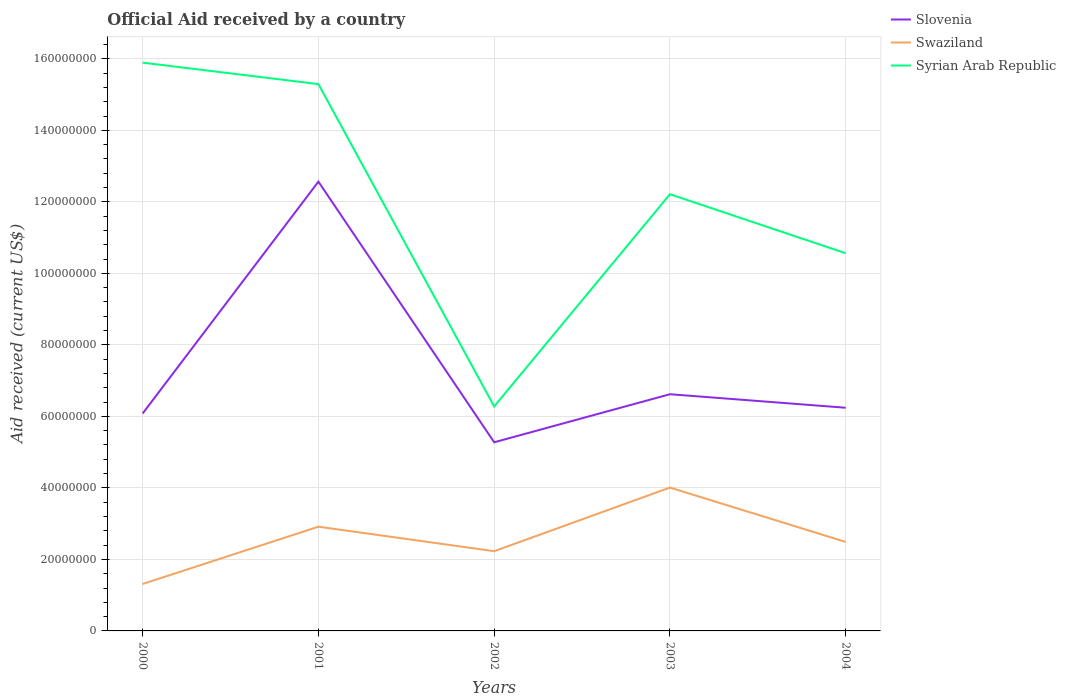How many different coloured lines are there?
Keep it short and to the point. 3. Is the number of lines equal to the number of legend labels?
Provide a short and direct response. Yes. Across all years, what is the maximum net official aid received in Slovenia?
Make the answer very short. 5.28e+07. What is the total net official aid received in Slovenia in the graph?
Your response must be concise. -5.39e+06. What is the difference between the highest and the second highest net official aid received in Syrian Arab Republic?
Provide a short and direct response. 9.62e+07. How many lines are there?
Offer a terse response. 3. Are the values on the major ticks of Y-axis written in scientific E-notation?
Offer a very short reply. No. Does the graph contain any zero values?
Offer a terse response. No. Does the graph contain grids?
Offer a very short reply. Yes. Where does the legend appear in the graph?
Provide a succinct answer. Top right. How many legend labels are there?
Offer a terse response. 3. How are the legend labels stacked?
Ensure brevity in your answer.  Vertical. What is the title of the graph?
Your answer should be compact. Official Aid received by a country. What is the label or title of the X-axis?
Provide a short and direct response. Years. What is the label or title of the Y-axis?
Ensure brevity in your answer.  Aid received (current US$). What is the Aid received (current US$) in Slovenia in 2000?
Your answer should be very brief. 6.08e+07. What is the Aid received (current US$) in Swaziland in 2000?
Offer a terse response. 1.31e+07. What is the Aid received (current US$) in Syrian Arab Republic in 2000?
Keep it short and to the point. 1.59e+08. What is the Aid received (current US$) in Slovenia in 2001?
Offer a terse response. 1.26e+08. What is the Aid received (current US$) in Swaziland in 2001?
Offer a very short reply. 2.92e+07. What is the Aid received (current US$) in Syrian Arab Republic in 2001?
Offer a terse response. 1.53e+08. What is the Aid received (current US$) of Slovenia in 2002?
Offer a very short reply. 5.28e+07. What is the Aid received (current US$) of Swaziland in 2002?
Provide a succinct answer. 2.23e+07. What is the Aid received (current US$) of Syrian Arab Republic in 2002?
Your answer should be compact. 6.28e+07. What is the Aid received (current US$) of Slovenia in 2003?
Your answer should be compact. 6.62e+07. What is the Aid received (current US$) in Swaziland in 2003?
Offer a terse response. 4.01e+07. What is the Aid received (current US$) in Syrian Arab Republic in 2003?
Provide a succinct answer. 1.22e+08. What is the Aid received (current US$) in Slovenia in 2004?
Make the answer very short. 6.24e+07. What is the Aid received (current US$) in Swaziland in 2004?
Provide a short and direct response. 2.49e+07. What is the Aid received (current US$) in Syrian Arab Republic in 2004?
Keep it short and to the point. 1.06e+08. Across all years, what is the maximum Aid received (current US$) in Slovenia?
Ensure brevity in your answer.  1.26e+08. Across all years, what is the maximum Aid received (current US$) in Swaziland?
Offer a very short reply. 4.01e+07. Across all years, what is the maximum Aid received (current US$) in Syrian Arab Republic?
Provide a succinct answer. 1.59e+08. Across all years, what is the minimum Aid received (current US$) of Slovenia?
Ensure brevity in your answer.  5.28e+07. Across all years, what is the minimum Aid received (current US$) in Swaziland?
Offer a terse response. 1.31e+07. Across all years, what is the minimum Aid received (current US$) of Syrian Arab Republic?
Make the answer very short. 6.28e+07. What is the total Aid received (current US$) of Slovenia in the graph?
Provide a short and direct response. 3.68e+08. What is the total Aid received (current US$) in Swaziland in the graph?
Make the answer very short. 1.30e+08. What is the total Aid received (current US$) in Syrian Arab Republic in the graph?
Make the answer very short. 6.02e+08. What is the difference between the Aid received (current US$) of Slovenia in 2000 and that in 2001?
Offer a very short reply. -6.48e+07. What is the difference between the Aid received (current US$) of Swaziland in 2000 and that in 2001?
Your response must be concise. -1.60e+07. What is the difference between the Aid received (current US$) in Slovenia in 2000 and that in 2002?
Provide a short and direct response. 8.05e+06. What is the difference between the Aid received (current US$) in Swaziland in 2000 and that in 2002?
Your response must be concise. -9.17e+06. What is the difference between the Aid received (current US$) in Syrian Arab Republic in 2000 and that in 2002?
Offer a very short reply. 9.62e+07. What is the difference between the Aid received (current US$) in Slovenia in 2000 and that in 2003?
Your answer should be compact. -5.39e+06. What is the difference between the Aid received (current US$) in Swaziland in 2000 and that in 2003?
Ensure brevity in your answer.  -2.70e+07. What is the difference between the Aid received (current US$) in Syrian Arab Republic in 2000 and that in 2003?
Your answer should be very brief. 3.68e+07. What is the difference between the Aid received (current US$) of Slovenia in 2000 and that in 2004?
Make the answer very short. -1.61e+06. What is the difference between the Aid received (current US$) in Swaziland in 2000 and that in 2004?
Make the answer very short. -1.18e+07. What is the difference between the Aid received (current US$) of Syrian Arab Republic in 2000 and that in 2004?
Your response must be concise. 5.33e+07. What is the difference between the Aid received (current US$) in Slovenia in 2001 and that in 2002?
Ensure brevity in your answer.  7.29e+07. What is the difference between the Aid received (current US$) of Swaziland in 2001 and that in 2002?
Provide a succinct answer. 6.85e+06. What is the difference between the Aid received (current US$) in Syrian Arab Republic in 2001 and that in 2002?
Provide a short and direct response. 9.02e+07. What is the difference between the Aid received (current US$) in Slovenia in 2001 and that in 2003?
Your answer should be compact. 5.95e+07. What is the difference between the Aid received (current US$) in Swaziland in 2001 and that in 2003?
Keep it short and to the point. -1.09e+07. What is the difference between the Aid received (current US$) of Syrian Arab Republic in 2001 and that in 2003?
Offer a terse response. 3.08e+07. What is the difference between the Aid received (current US$) in Slovenia in 2001 and that in 2004?
Your answer should be compact. 6.32e+07. What is the difference between the Aid received (current US$) of Swaziland in 2001 and that in 2004?
Offer a very short reply. 4.26e+06. What is the difference between the Aid received (current US$) of Syrian Arab Republic in 2001 and that in 2004?
Your answer should be compact. 4.73e+07. What is the difference between the Aid received (current US$) of Slovenia in 2002 and that in 2003?
Your response must be concise. -1.34e+07. What is the difference between the Aid received (current US$) in Swaziland in 2002 and that in 2003?
Your answer should be compact. -1.78e+07. What is the difference between the Aid received (current US$) of Syrian Arab Republic in 2002 and that in 2003?
Offer a very short reply. -5.94e+07. What is the difference between the Aid received (current US$) in Slovenia in 2002 and that in 2004?
Keep it short and to the point. -9.66e+06. What is the difference between the Aid received (current US$) of Swaziland in 2002 and that in 2004?
Make the answer very short. -2.59e+06. What is the difference between the Aid received (current US$) in Syrian Arab Republic in 2002 and that in 2004?
Ensure brevity in your answer.  -4.28e+07. What is the difference between the Aid received (current US$) in Slovenia in 2003 and that in 2004?
Make the answer very short. 3.78e+06. What is the difference between the Aid received (current US$) of Swaziland in 2003 and that in 2004?
Your answer should be very brief. 1.52e+07. What is the difference between the Aid received (current US$) of Syrian Arab Republic in 2003 and that in 2004?
Ensure brevity in your answer.  1.65e+07. What is the difference between the Aid received (current US$) in Slovenia in 2000 and the Aid received (current US$) in Swaziland in 2001?
Give a very brief answer. 3.17e+07. What is the difference between the Aid received (current US$) of Slovenia in 2000 and the Aid received (current US$) of Syrian Arab Republic in 2001?
Your response must be concise. -9.21e+07. What is the difference between the Aid received (current US$) in Swaziland in 2000 and the Aid received (current US$) in Syrian Arab Republic in 2001?
Your response must be concise. -1.40e+08. What is the difference between the Aid received (current US$) in Slovenia in 2000 and the Aid received (current US$) in Swaziland in 2002?
Your answer should be very brief. 3.85e+07. What is the difference between the Aid received (current US$) of Slovenia in 2000 and the Aid received (current US$) of Syrian Arab Republic in 2002?
Make the answer very short. -1.97e+06. What is the difference between the Aid received (current US$) of Swaziland in 2000 and the Aid received (current US$) of Syrian Arab Republic in 2002?
Your response must be concise. -4.96e+07. What is the difference between the Aid received (current US$) of Slovenia in 2000 and the Aid received (current US$) of Swaziland in 2003?
Offer a terse response. 2.07e+07. What is the difference between the Aid received (current US$) in Slovenia in 2000 and the Aid received (current US$) in Syrian Arab Republic in 2003?
Give a very brief answer. -6.13e+07. What is the difference between the Aid received (current US$) of Swaziland in 2000 and the Aid received (current US$) of Syrian Arab Republic in 2003?
Give a very brief answer. -1.09e+08. What is the difference between the Aid received (current US$) of Slovenia in 2000 and the Aid received (current US$) of Swaziland in 2004?
Your answer should be very brief. 3.59e+07. What is the difference between the Aid received (current US$) in Slovenia in 2000 and the Aid received (current US$) in Syrian Arab Republic in 2004?
Your answer should be compact. -4.48e+07. What is the difference between the Aid received (current US$) of Swaziland in 2000 and the Aid received (current US$) of Syrian Arab Republic in 2004?
Make the answer very short. -9.25e+07. What is the difference between the Aid received (current US$) in Slovenia in 2001 and the Aid received (current US$) in Swaziland in 2002?
Your response must be concise. 1.03e+08. What is the difference between the Aid received (current US$) of Slovenia in 2001 and the Aid received (current US$) of Syrian Arab Republic in 2002?
Offer a very short reply. 6.29e+07. What is the difference between the Aid received (current US$) in Swaziland in 2001 and the Aid received (current US$) in Syrian Arab Republic in 2002?
Your answer should be compact. -3.36e+07. What is the difference between the Aid received (current US$) of Slovenia in 2001 and the Aid received (current US$) of Swaziland in 2003?
Offer a terse response. 8.56e+07. What is the difference between the Aid received (current US$) of Slovenia in 2001 and the Aid received (current US$) of Syrian Arab Republic in 2003?
Your answer should be compact. 3.52e+06. What is the difference between the Aid received (current US$) of Swaziland in 2001 and the Aid received (current US$) of Syrian Arab Republic in 2003?
Provide a short and direct response. -9.30e+07. What is the difference between the Aid received (current US$) of Slovenia in 2001 and the Aid received (current US$) of Swaziland in 2004?
Give a very brief answer. 1.01e+08. What is the difference between the Aid received (current US$) of Slovenia in 2001 and the Aid received (current US$) of Syrian Arab Republic in 2004?
Keep it short and to the point. 2.00e+07. What is the difference between the Aid received (current US$) in Swaziland in 2001 and the Aid received (current US$) in Syrian Arab Republic in 2004?
Your response must be concise. -7.65e+07. What is the difference between the Aid received (current US$) of Slovenia in 2002 and the Aid received (current US$) of Swaziland in 2003?
Keep it short and to the point. 1.27e+07. What is the difference between the Aid received (current US$) of Slovenia in 2002 and the Aid received (current US$) of Syrian Arab Republic in 2003?
Provide a succinct answer. -6.94e+07. What is the difference between the Aid received (current US$) of Swaziland in 2002 and the Aid received (current US$) of Syrian Arab Republic in 2003?
Your answer should be very brief. -9.98e+07. What is the difference between the Aid received (current US$) in Slovenia in 2002 and the Aid received (current US$) in Swaziland in 2004?
Your response must be concise. 2.79e+07. What is the difference between the Aid received (current US$) in Slovenia in 2002 and the Aid received (current US$) in Syrian Arab Republic in 2004?
Give a very brief answer. -5.29e+07. What is the difference between the Aid received (current US$) of Swaziland in 2002 and the Aid received (current US$) of Syrian Arab Republic in 2004?
Keep it short and to the point. -8.33e+07. What is the difference between the Aid received (current US$) in Slovenia in 2003 and the Aid received (current US$) in Swaziland in 2004?
Offer a terse response. 4.13e+07. What is the difference between the Aid received (current US$) of Slovenia in 2003 and the Aid received (current US$) of Syrian Arab Republic in 2004?
Your response must be concise. -3.94e+07. What is the difference between the Aid received (current US$) in Swaziland in 2003 and the Aid received (current US$) in Syrian Arab Republic in 2004?
Your answer should be compact. -6.55e+07. What is the average Aid received (current US$) in Slovenia per year?
Your answer should be compact. 7.36e+07. What is the average Aid received (current US$) in Swaziland per year?
Provide a succinct answer. 2.59e+07. What is the average Aid received (current US$) in Syrian Arab Republic per year?
Your answer should be very brief. 1.20e+08. In the year 2000, what is the difference between the Aid received (current US$) of Slovenia and Aid received (current US$) of Swaziland?
Offer a terse response. 4.77e+07. In the year 2000, what is the difference between the Aid received (current US$) of Slovenia and Aid received (current US$) of Syrian Arab Republic?
Your answer should be very brief. -9.81e+07. In the year 2000, what is the difference between the Aid received (current US$) in Swaziland and Aid received (current US$) in Syrian Arab Republic?
Your answer should be compact. -1.46e+08. In the year 2001, what is the difference between the Aid received (current US$) of Slovenia and Aid received (current US$) of Swaziland?
Provide a short and direct response. 9.65e+07. In the year 2001, what is the difference between the Aid received (current US$) of Slovenia and Aid received (current US$) of Syrian Arab Republic?
Make the answer very short. -2.73e+07. In the year 2001, what is the difference between the Aid received (current US$) in Swaziland and Aid received (current US$) in Syrian Arab Republic?
Provide a short and direct response. -1.24e+08. In the year 2002, what is the difference between the Aid received (current US$) of Slovenia and Aid received (current US$) of Swaziland?
Make the answer very short. 3.05e+07. In the year 2002, what is the difference between the Aid received (current US$) of Slovenia and Aid received (current US$) of Syrian Arab Republic?
Your response must be concise. -1.00e+07. In the year 2002, what is the difference between the Aid received (current US$) in Swaziland and Aid received (current US$) in Syrian Arab Republic?
Ensure brevity in your answer.  -4.05e+07. In the year 2003, what is the difference between the Aid received (current US$) in Slovenia and Aid received (current US$) in Swaziland?
Offer a terse response. 2.61e+07. In the year 2003, what is the difference between the Aid received (current US$) in Slovenia and Aid received (current US$) in Syrian Arab Republic?
Keep it short and to the point. -5.59e+07. In the year 2003, what is the difference between the Aid received (current US$) of Swaziland and Aid received (current US$) of Syrian Arab Republic?
Your answer should be compact. -8.20e+07. In the year 2004, what is the difference between the Aid received (current US$) of Slovenia and Aid received (current US$) of Swaziland?
Give a very brief answer. 3.75e+07. In the year 2004, what is the difference between the Aid received (current US$) in Slovenia and Aid received (current US$) in Syrian Arab Republic?
Provide a short and direct response. -4.32e+07. In the year 2004, what is the difference between the Aid received (current US$) in Swaziland and Aid received (current US$) in Syrian Arab Republic?
Offer a terse response. -8.07e+07. What is the ratio of the Aid received (current US$) of Slovenia in 2000 to that in 2001?
Your answer should be compact. 0.48. What is the ratio of the Aid received (current US$) of Swaziland in 2000 to that in 2001?
Give a very brief answer. 0.45. What is the ratio of the Aid received (current US$) in Syrian Arab Republic in 2000 to that in 2001?
Your response must be concise. 1.04. What is the ratio of the Aid received (current US$) in Slovenia in 2000 to that in 2002?
Offer a terse response. 1.15. What is the ratio of the Aid received (current US$) of Swaziland in 2000 to that in 2002?
Offer a terse response. 0.59. What is the ratio of the Aid received (current US$) of Syrian Arab Republic in 2000 to that in 2002?
Offer a very short reply. 2.53. What is the ratio of the Aid received (current US$) in Slovenia in 2000 to that in 2003?
Make the answer very short. 0.92. What is the ratio of the Aid received (current US$) of Swaziland in 2000 to that in 2003?
Your response must be concise. 0.33. What is the ratio of the Aid received (current US$) of Syrian Arab Republic in 2000 to that in 2003?
Ensure brevity in your answer.  1.3. What is the ratio of the Aid received (current US$) of Slovenia in 2000 to that in 2004?
Your response must be concise. 0.97. What is the ratio of the Aid received (current US$) of Swaziland in 2000 to that in 2004?
Keep it short and to the point. 0.53. What is the ratio of the Aid received (current US$) in Syrian Arab Republic in 2000 to that in 2004?
Provide a short and direct response. 1.5. What is the ratio of the Aid received (current US$) in Slovenia in 2001 to that in 2002?
Provide a succinct answer. 2.38. What is the ratio of the Aid received (current US$) of Swaziland in 2001 to that in 2002?
Your response must be concise. 1.31. What is the ratio of the Aid received (current US$) of Syrian Arab Republic in 2001 to that in 2002?
Give a very brief answer. 2.44. What is the ratio of the Aid received (current US$) of Slovenia in 2001 to that in 2003?
Keep it short and to the point. 1.9. What is the ratio of the Aid received (current US$) of Swaziland in 2001 to that in 2003?
Your answer should be very brief. 0.73. What is the ratio of the Aid received (current US$) in Syrian Arab Republic in 2001 to that in 2003?
Your answer should be very brief. 1.25. What is the ratio of the Aid received (current US$) in Slovenia in 2001 to that in 2004?
Your answer should be compact. 2.01. What is the ratio of the Aid received (current US$) of Swaziland in 2001 to that in 2004?
Your answer should be very brief. 1.17. What is the ratio of the Aid received (current US$) of Syrian Arab Republic in 2001 to that in 2004?
Give a very brief answer. 1.45. What is the ratio of the Aid received (current US$) of Slovenia in 2002 to that in 2003?
Keep it short and to the point. 0.8. What is the ratio of the Aid received (current US$) of Swaziland in 2002 to that in 2003?
Ensure brevity in your answer.  0.56. What is the ratio of the Aid received (current US$) in Syrian Arab Republic in 2002 to that in 2003?
Your answer should be compact. 0.51. What is the ratio of the Aid received (current US$) of Slovenia in 2002 to that in 2004?
Keep it short and to the point. 0.85. What is the ratio of the Aid received (current US$) of Swaziland in 2002 to that in 2004?
Ensure brevity in your answer.  0.9. What is the ratio of the Aid received (current US$) of Syrian Arab Republic in 2002 to that in 2004?
Make the answer very short. 0.59. What is the ratio of the Aid received (current US$) in Slovenia in 2003 to that in 2004?
Your response must be concise. 1.06. What is the ratio of the Aid received (current US$) of Swaziland in 2003 to that in 2004?
Your response must be concise. 1.61. What is the ratio of the Aid received (current US$) in Syrian Arab Republic in 2003 to that in 2004?
Keep it short and to the point. 1.16. What is the difference between the highest and the second highest Aid received (current US$) in Slovenia?
Provide a short and direct response. 5.95e+07. What is the difference between the highest and the second highest Aid received (current US$) of Swaziland?
Ensure brevity in your answer.  1.09e+07. What is the difference between the highest and the lowest Aid received (current US$) of Slovenia?
Give a very brief answer. 7.29e+07. What is the difference between the highest and the lowest Aid received (current US$) of Swaziland?
Offer a terse response. 2.70e+07. What is the difference between the highest and the lowest Aid received (current US$) of Syrian Arab Republic?
Make the answer very short. 9.62e+07. 